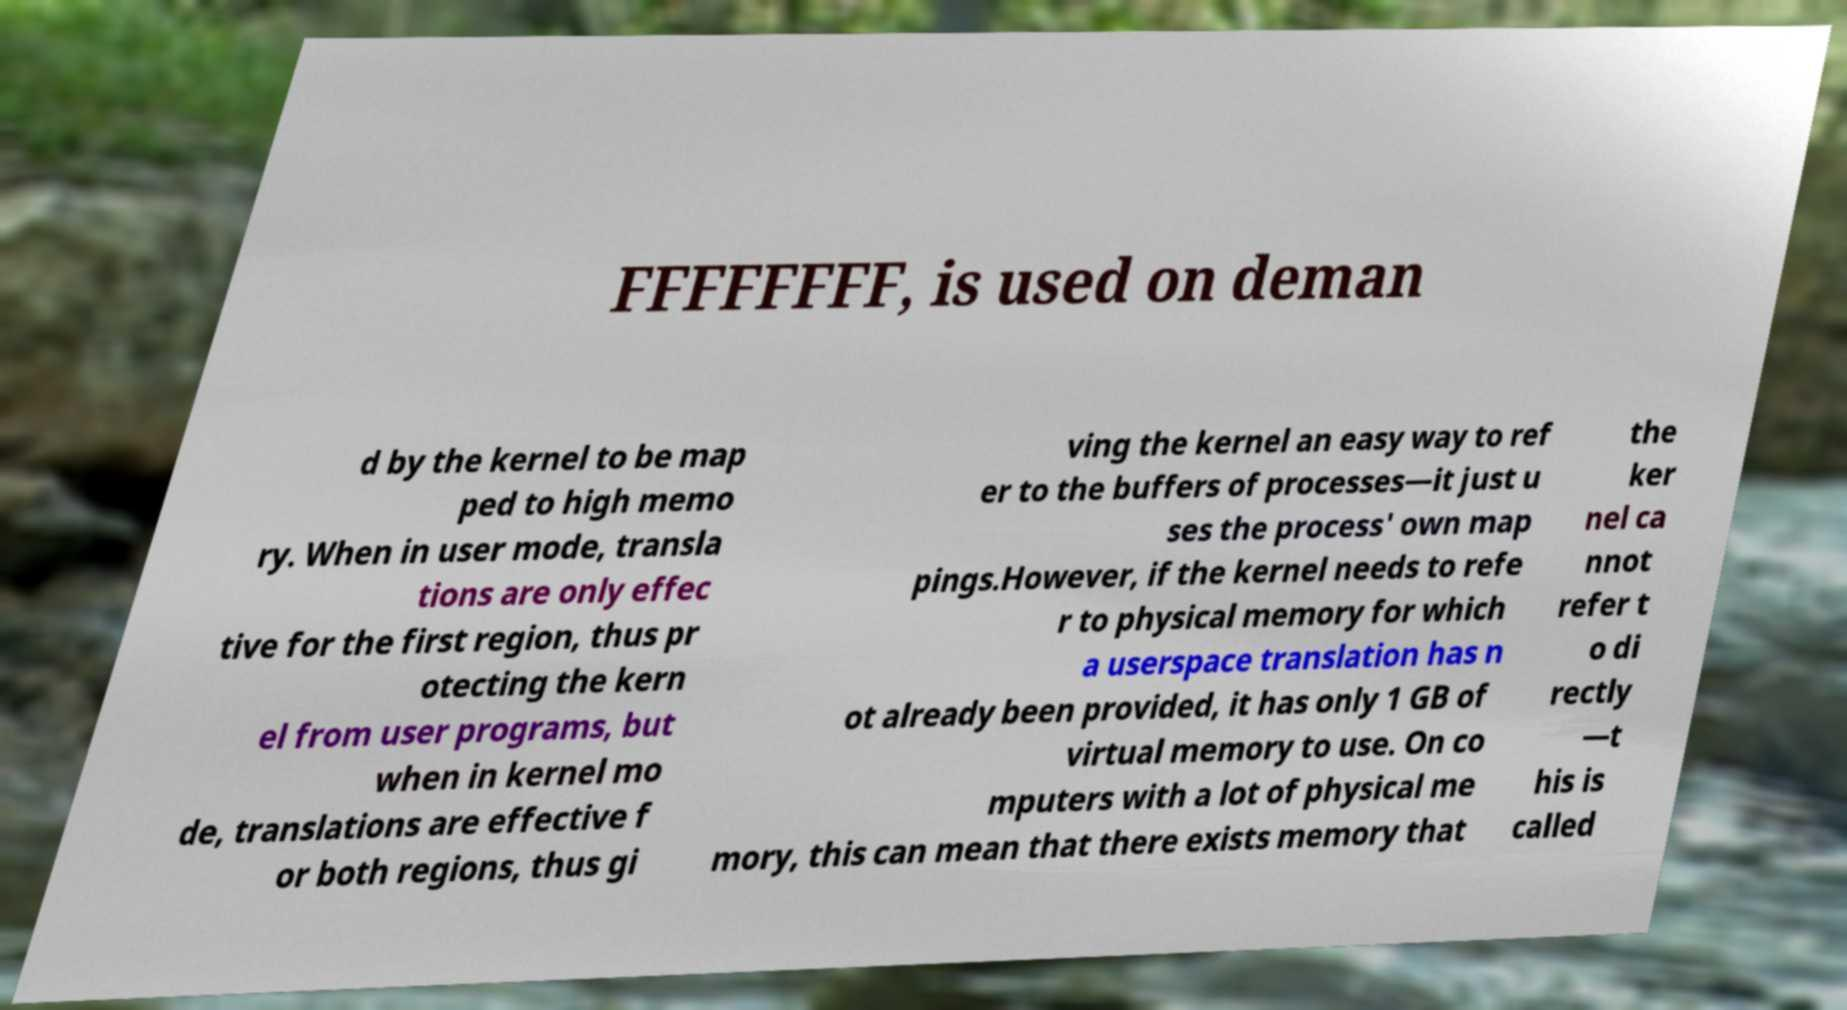Please identify and transcribe the text found in this image. FFFFFFFF, is used on deman d by the kernel to be map ped to high memo ry. When in user mode, transla tions are only effec tive for the first region, thus pr otecting the kern el from user programs, but when in kernel mo de, translations are effective f or both regions, thus gi ving the kernel an easy way to ref er to the buffers of processes—it just u ses the process' own map pings.However, if the kernel needs to refe r to physical memory for which a userspace translation has n ot already been provided, it has only 1 GB of virtual memory to use. On co mputers with a lot of physical me mory, this can mean that there exists memory that the ker nel ca nnot refer t o di rectly —t his is called 